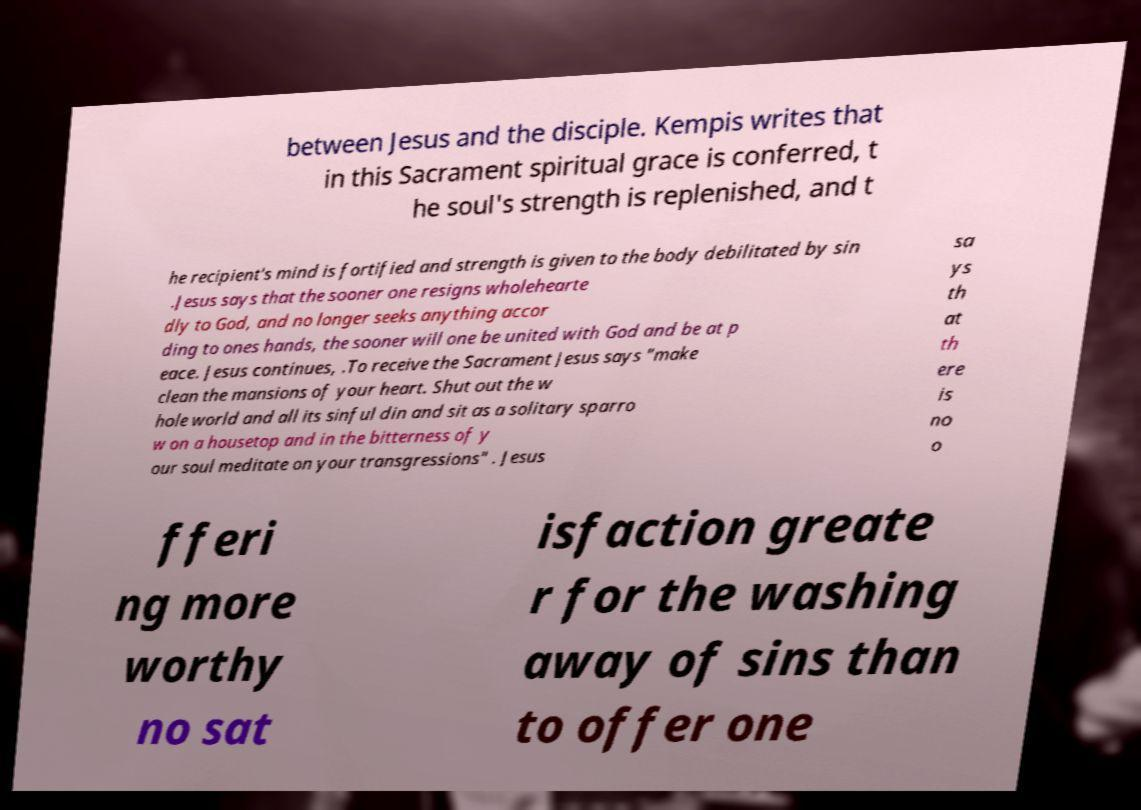Please read and relay the text visible in this image. What does it say? between Jesus and the disciple. Kempis writes that in this Sacrament spiritual grace is conferred, t he soul's strength is replenished, and t he recipient's mind is fortified and strength is given to the body debilitated by sin .Jesus says that the sooner one resigns wholehearte dly to God, and no longer seeks anything accor ding to ones hands, the sooner will one be united with God and be at p eace. Jesus continues, .To receive the Sacrament Jesus says "make clean the mansions of your heart. Shut out the w hole world and all its sinful din and sit as a solitary sparro w on a housetop and in the bitterness of y our soul meditate on your transgressions" . Jesus sa ys th at th ere is no o fferi ng more worthy no sat isfaction greate r for the washing away of sins than to offer one 